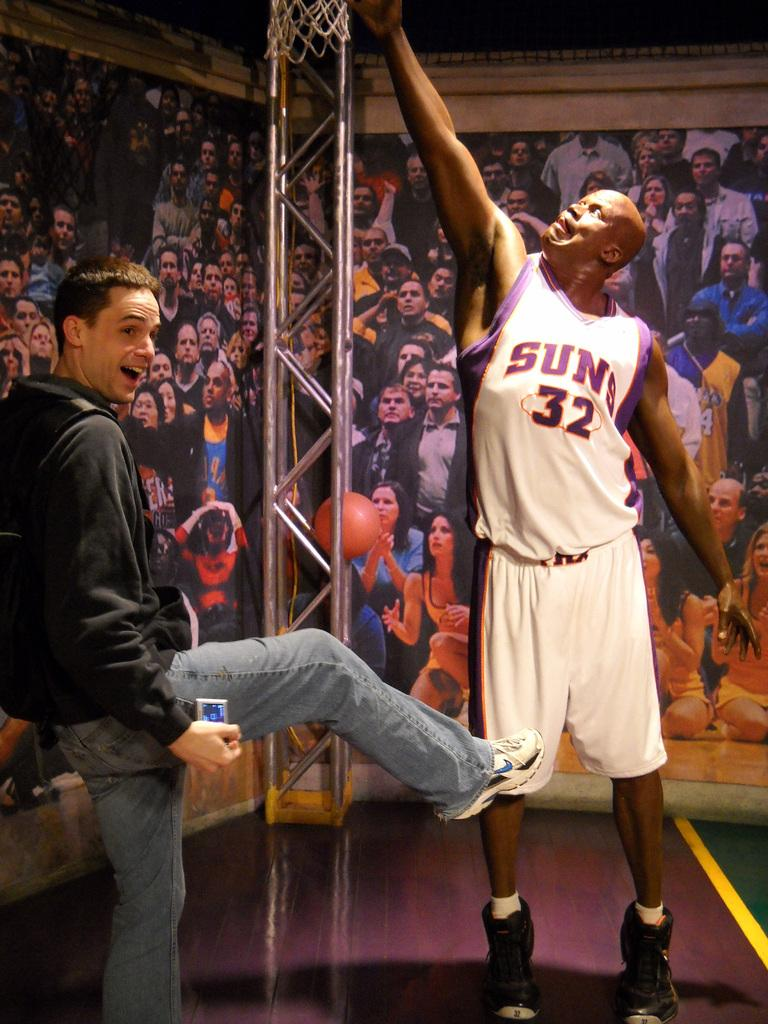<image>
Render a clear and concise summary of the photo. a man is standing near a basketball palyer number 32 